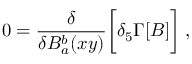<formula> <loc_0><loc_0><loc_500><loc_500>0 = { \frac { \delta } { \delta B _ { a } ^ { b } ( x y ) } } \left [ \delta _ { 5 } \Gamma [ B ] \right ] \, ,</formula> 